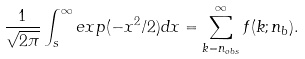<formula> <loc_0><loc_0><loc_500><loc_500>\frac { 1 } { \sqrt { 2 \pi } } \int _ { s } ^ { \infty } e x p ( - x ^ { 2 } / 2 ) d x = \sum _ { k = n _ { o b s } } ^ { \infty } f ( k ; n _ { b } ) .</formula> 